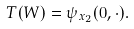<formula> <loc_0><loc_0><loc_500><loc_500>T ( W ) = \psi _ { x _ { 2 } } ( 0 , \cdot ) .</formula> 